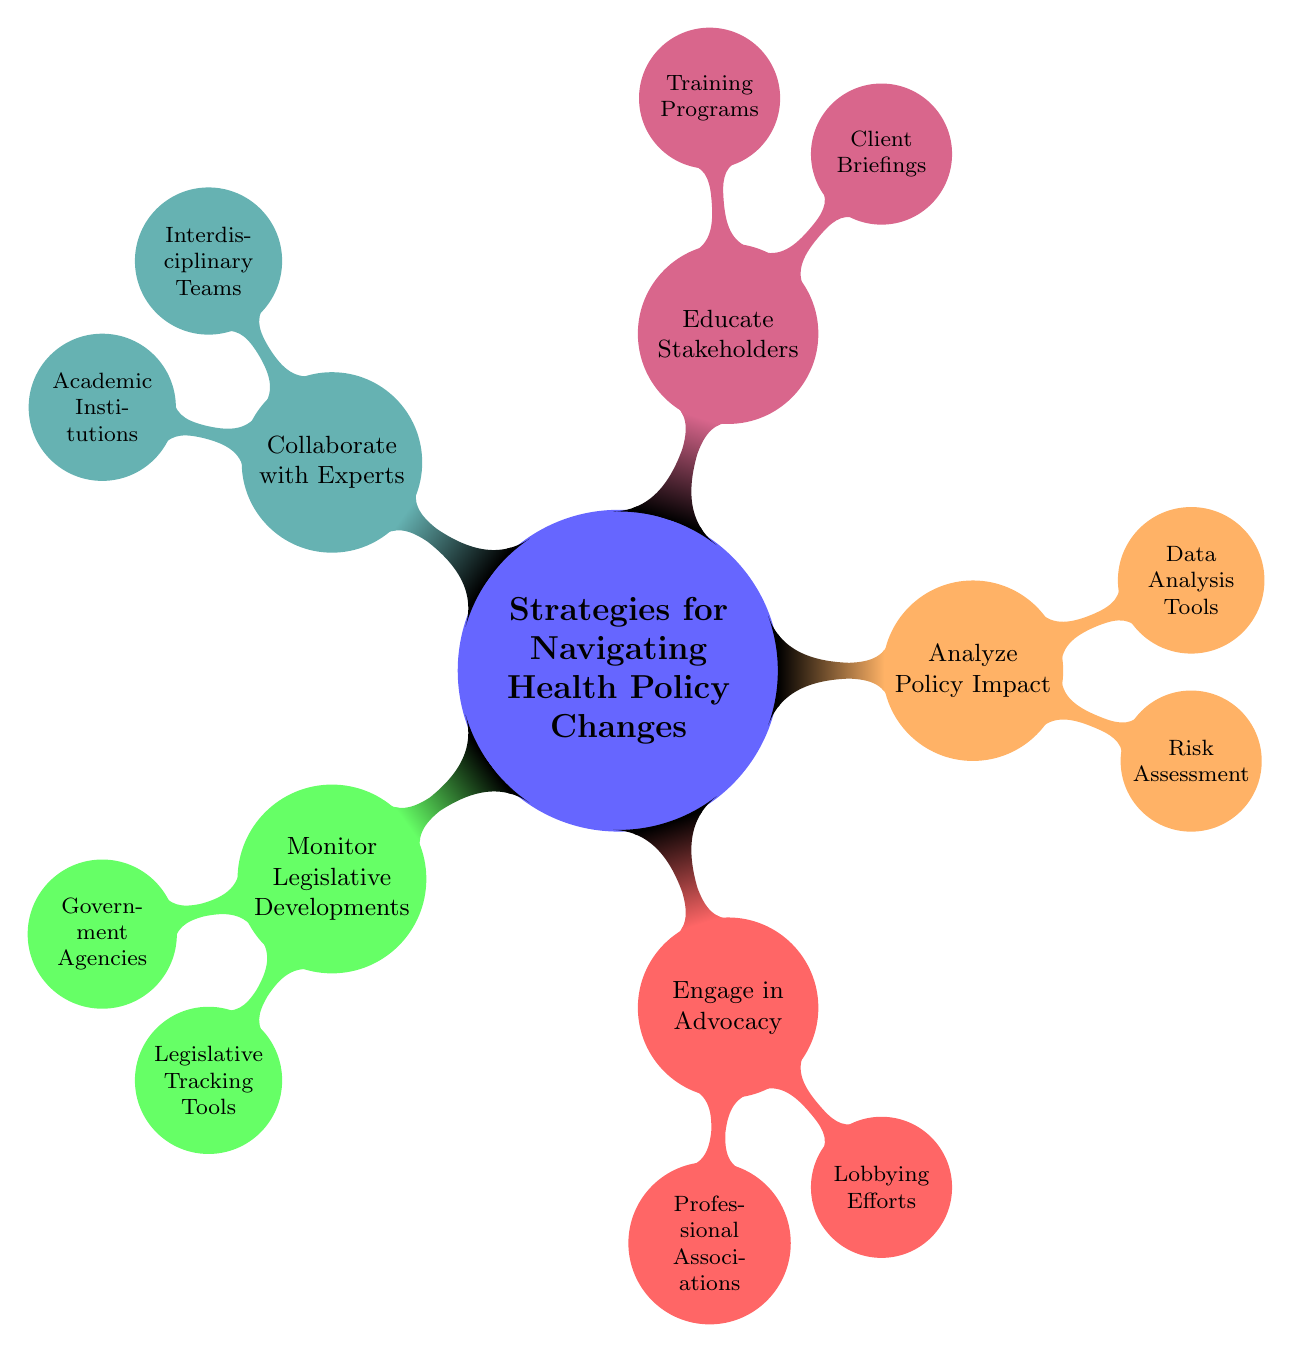what is the top-level node in the diagram? The top-level node represents the main theme of the mind map, which is "Strategies for Navigating Health Policy Changes." This can be identified as it is the central concept from which all other nodes branch out.
Answer: Strategies for Navigating Health Policy Changes how many main strategies are identified in the diagram? By counting the distinct child nodes that represent each main strategy branching from the top-level node, we find there are five strategies: Monitor Legislative Developments, Engage in Advocacy, Analyze Policy Impact, Educate Stakeholders, and Collaborate with Experts.
Answer: 5 which node is associated with "Risk Assessment"? The node "Risk Assessment" is a child of the node "Analyze Policy Impact." To find that, we follow the hierarchy down to the second level of nodes, specifically looking at where "Risk Assessment" is located.
Answer: Analyze Policy Impact what color represents the "Educate Stakeholders" strategy? Each strategy node in the mind map is color-coded, and the "Educate Stakeholders" strategy is represented in purple. This can be observed by looking at the color assigned to that specific child node.
Answer: purple which tools are listed under "Legislative Tracking Tools"? The child node under "Legislative Tracking Tools" details specific tracking resources, which are "Congress.gov," "State Scape," and "GovTrack.us." These are listed as children of the "Legislative Tracking Tools" node.
Answer: Congress.gov, State Scape, GovTrack.us name one type of organization that can be part of "Interdisciplinary Teams." The node "Interdisciplinary Teams" includes multiple types of organizations, one of which is "Policy Analysts." This can be found by identifying the specific child nodes branching from the "Collaborate with Experts" node.
Answer: Policy Analysts how does "Risk Assessment" relate to "Analyze Policy Impact"? "Risk Assessment" is a specific aspect or component that falls under the broader category of "Analyze Policy Impact." The relationship is hierarchical, indicating that risk assessment is part of the broader analysis of policy impact.
Answer: it is a child node which professional association is mentioned under "Engage in Advocacy"? The node "Engage in Advocacy" lists "American Health Lawyers Association" as one of the professional associations. This information can be gathered from the child nodes associated with "Engage in Advocacy."
Answer: American Health Lawyers Association what is the focus of the node "Educate Stakeholders"? The focus of the "Educate Stakeholders" node is on informing and training individuals associated with the health policy landscape, which is captured in its child nodes: "Client Briefings" and "Training Programs."
Answer: informing and training individuals 